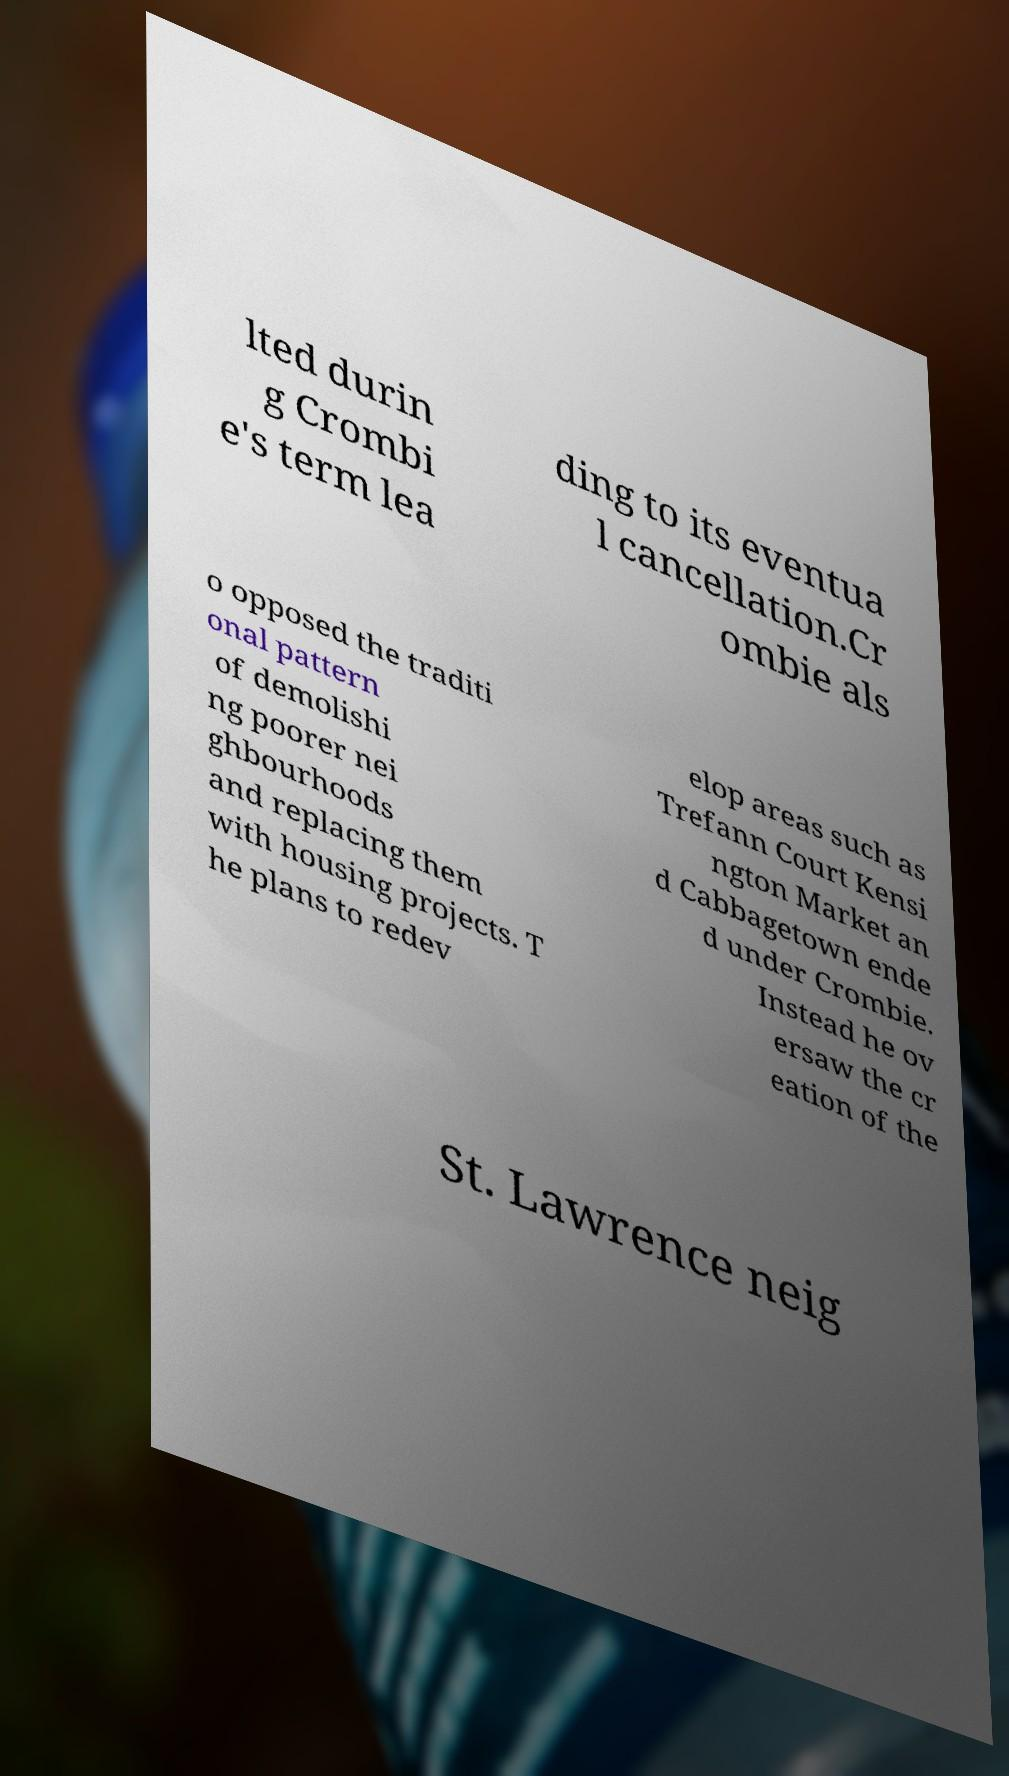For documentation purposes, I need the text within this image transcribed. Could you provide that? lted durin g Crombi e's term lea ding to its eventua l cancellation.Cr ombie als o opposed the traditi onal pattern of demolishi ng poorer nei ghbourhoods and replacing them with housing projects. T he plans to redev elop areas such as Trefann Court Kensi ngton Market an d Cabbagetown ende d under Crombie. Instead he ov ersaw the cr eation of the St. Lawrence neig 